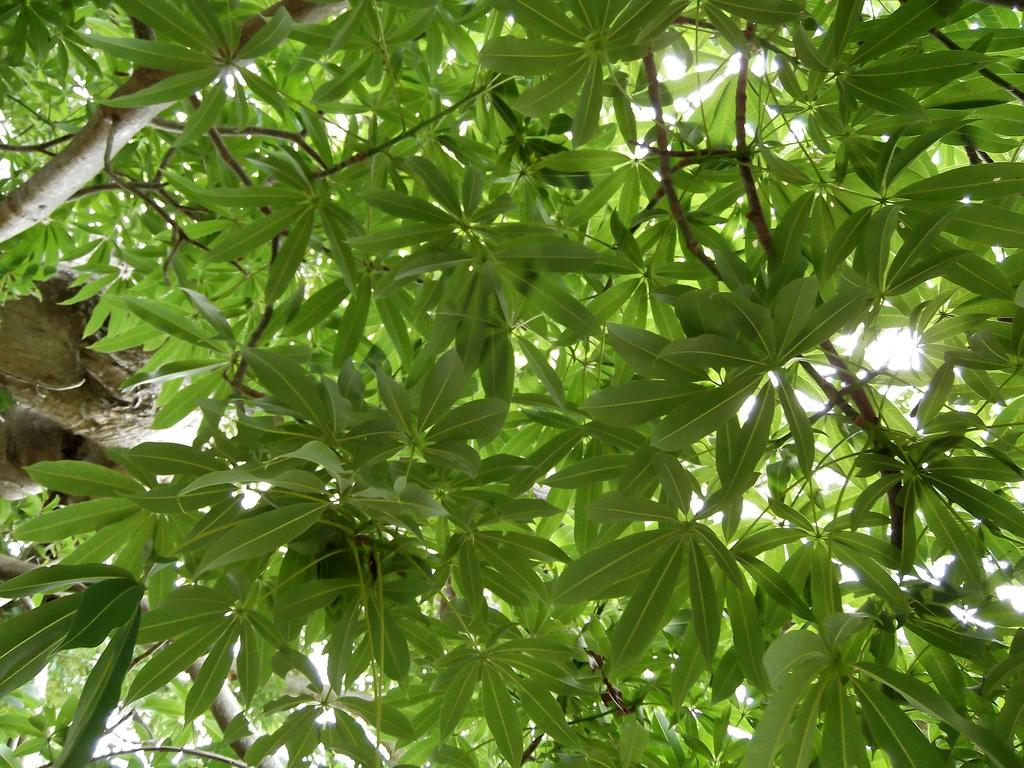What type of vegetation can be seen in the image? There are trees in the image. What colors are the trees in the image? The trees have green and brown colors. What is visible in the background of the image? The sky is visible in the background of the image. Where is the faucet located in the image? There is no faucet present in the image. What type of camp can be seen in the image? There is no camp present in the image. 